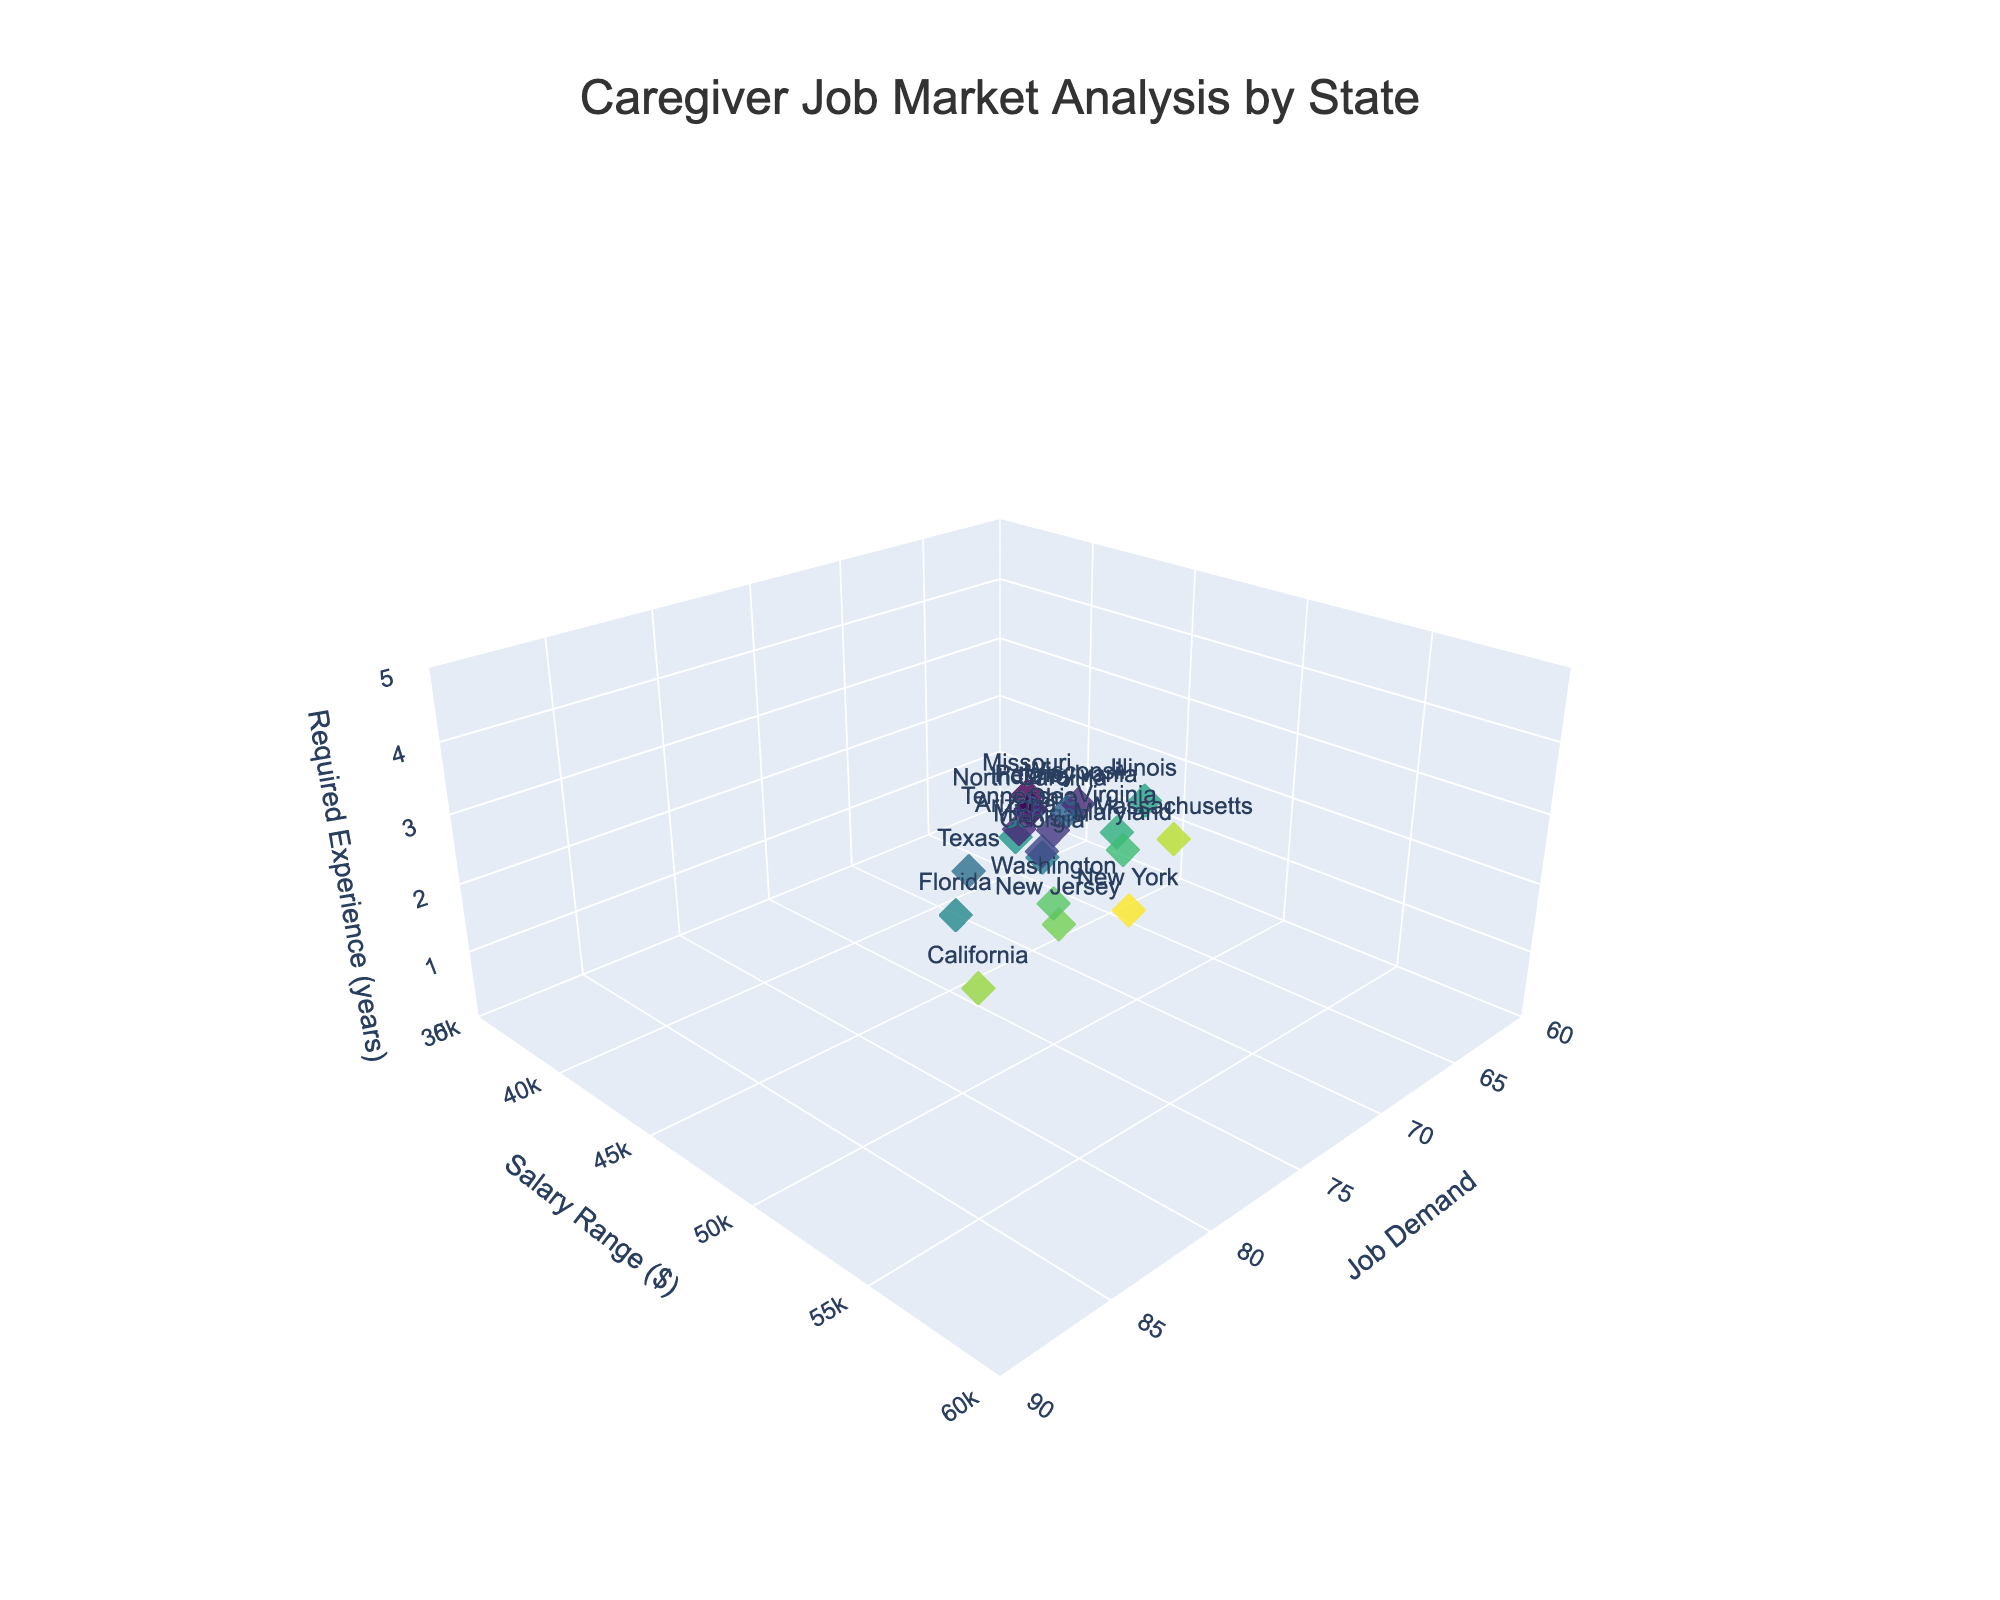What is the title of the plot? The title is usually displayed at the top of the plot and provides a brief description of what the plot is about. In this case, it reads "Caregiver Job Market Analysis by State"
Answer: Caregiver Job Market Analysis by State Which state has the highest job demand for caregivers? The state with the highest job demand will be the data point farthest along the x-axis. California has the highest job demand with a value of 85
Answer: California What is the salary range for caregivers in New York? By hovering over the data point marked "New York", the hover text shows the salary range, which is $58,000
Answer: $58,000 How many years of experience is required for caregivers in Texas? By examining the "Texas" data point, the z-axis value shows the required experience, which is 2 years
Answer: 2 years Which states have a required experience of 1 year? The required experience data points along the z-axis with a value of 1 indicate Ohio, Michigan, Tennessee, Indiana, Wisconsin, and Missouri
Answer: Ohio, Michigan, Tennessee, Indiana, Wisconsin, Missouri What is the average salary range across all states? Add all salary values and divide by the number of states: (55000 + 48000 + 58000 + 46000 + 50000 + 45000 + 42000 + 47000 + 44000 + 43000 + 49000 + 54000 + 51000 + 53000 + 56000 + 41000 + 40000 + 39000 + 52000 + 41000) / 20 = 47750
Answer: $47,750 Which state has the lowest salary range, and what is it? The lowest point on the y-axis across all salary ranges is $39,000 in Missouri
Answer: Missouri, $39,000 What is the difference in salary between the states with the highest and lowest job demand? The highest job demand is in California ($55,000) and the lowest job demand is in Missouri ($39,000). So, 55000 - 39000 = 16000
Answer: $16,000 Which state offers the highest salary range for caregivers with 3 years of required experience? For z-axis = 3 years, the highest y-axis value is $55,000 from California
Answer: California, $55,000 